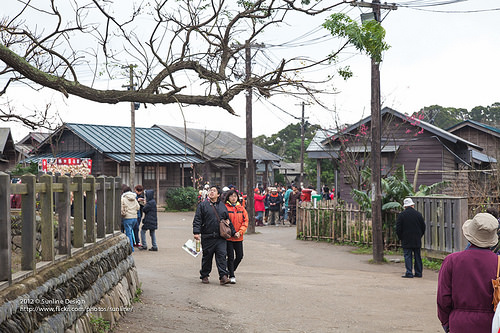<image>
Is the road under the man? Yes. The road is positioned underneath the man, with the man above it in the vertical space. Is there a sky behind the house? Yes. From this viewpoint, the sky is positioned behind the house, with the house partially or fully occluding the sky. Where is the lady in relation to the man? Is it in front of the man? No. The lady is not in front of the man. The spatial positioning shows a different relationship between these objects. 